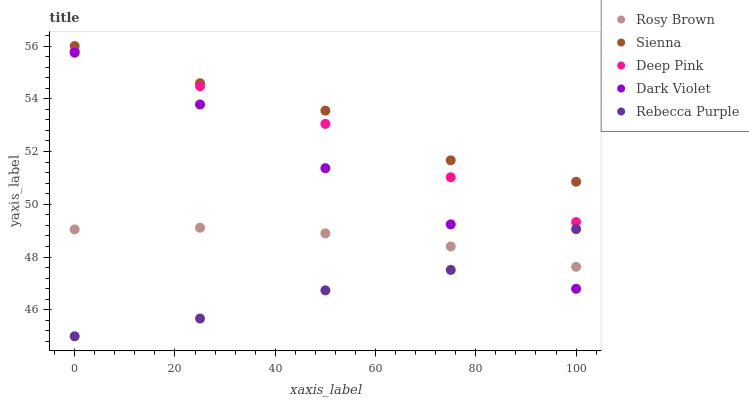Does Rebecca Purple have the minimum area under the curve?
Answer yes or no. Yes. Does Sienna have the maximum area under the curve?
Answer yes or no. Yes. Does Rosy Brown have the minimum area under the curve?
Answer yes or no. No. Does Rosy Brown have the maximum area under the curve?
Answer yes or no. No. Is Rosy Brown the smoothest?
Answer yes or no. Yes. Is Sienna the roughest?
Answer yes or no. Yes. Is Dark Violet the smoothest?
Answer yes or no. No. Is Dark Violet the roughest?
Answer yes or no. No. Does Rebecca Purple have the lowest value?
Answer yes or no. Yes. Does Rosy Brown have the lowest value?
Answer yes or no. No. Does Sienna have the highest value?
Answer yes or no. Yes. Does Rosy Brown have the highest value?
Answer yes or no. No. Is Deep Pink less than Sienna?
Answer yes or no. Yes. Is Deep Pink greater than Rebecca Purple?
Answer yes or no. Yes. Does Dark Violet intersect Rebecca Purple?
Answer yes or no. Yes. Is Dark Violet less than Rebecca Purple?
Answer yes or no. No. Is Dark Violet greater than Rebecca Purple?
Answer yes or no. No. Does Deep Pink intersect Sienna?
Answer yes or no. No. 